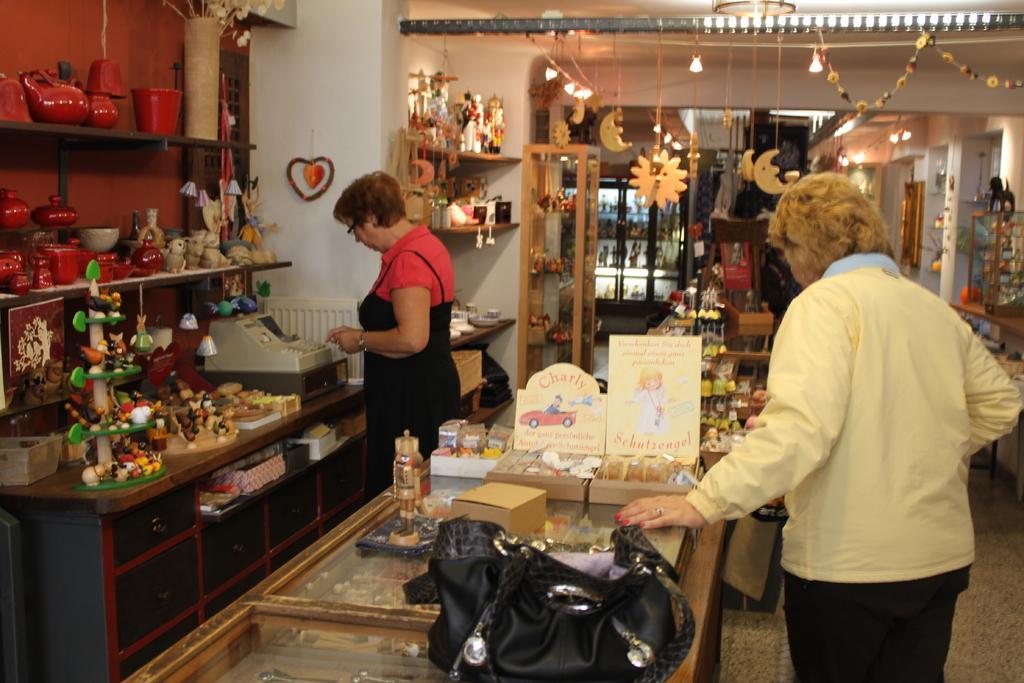In one or two sentences, can you explain what this image depicts? There are two persons standing and there is a table in front of them which has some objects on it. 